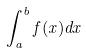Convert formula to latex. <formula><loc_0><loc_0><loc_500><loc_500>\int _ { a } ^ { b } f ( x ) d x</formula> 